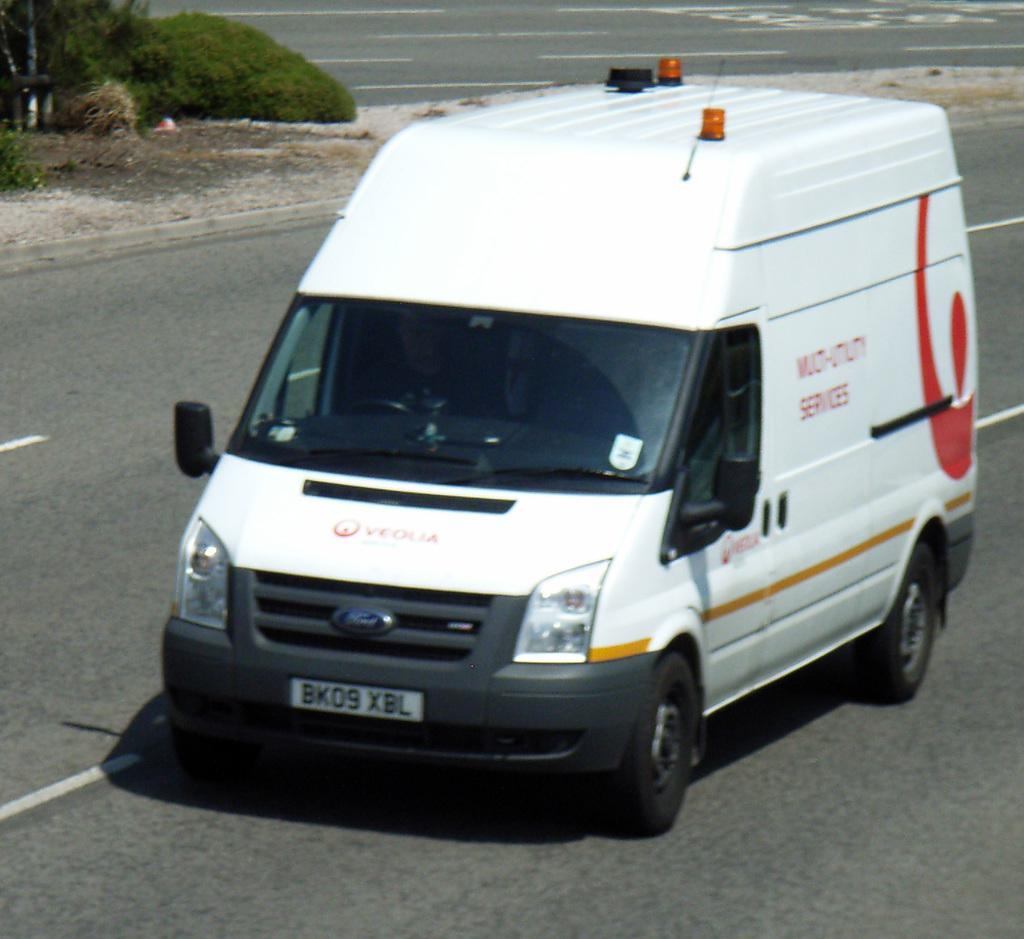<image>
Share a concise interpretation of the image provided. A utility services van is driving down a street. 